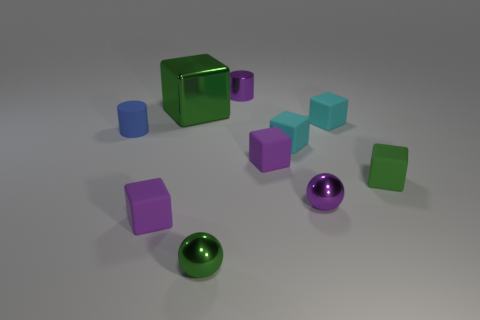There is a purple sphere that is the same size as the matte cylinder; what material is it?
Offer a very short reply. Metal. Are there any green cylinders that have the same material as the large green cube?
Make the answer very short. No. There is a green shiny object to the right of the block behind the matte object behind the tiny blue matte thing; what is its shape?
Give a very brief answer. Sphere. Do the green shiny block and the rubber block behind the tiny rubber cylinder have the same size?
Give a very brief answer. No. There is a tiny object that is behind the tiny matte cylinder and in front of the metallic block; what shape is it?
Your response must be concise. Cube. What number of large things are either green things or yellow rubber blocks?
Ensure brevity in your answer.  1. Are there an equal number of green metallic objects that are in front of the blue rubber object and purple matte things behind the small purple metallic ball?
Make the answer very short. Yes. What number of other objects are there of the same color as the big metal object?
Provide a succinct answer. 2. Are there the same number of small blocks behind the green rubber block and purple objects?
Your answer should be very brief. No. Does the green shiny ball have the same size as the blue rubber cylinder?
Offer a very short reply. Yes. 